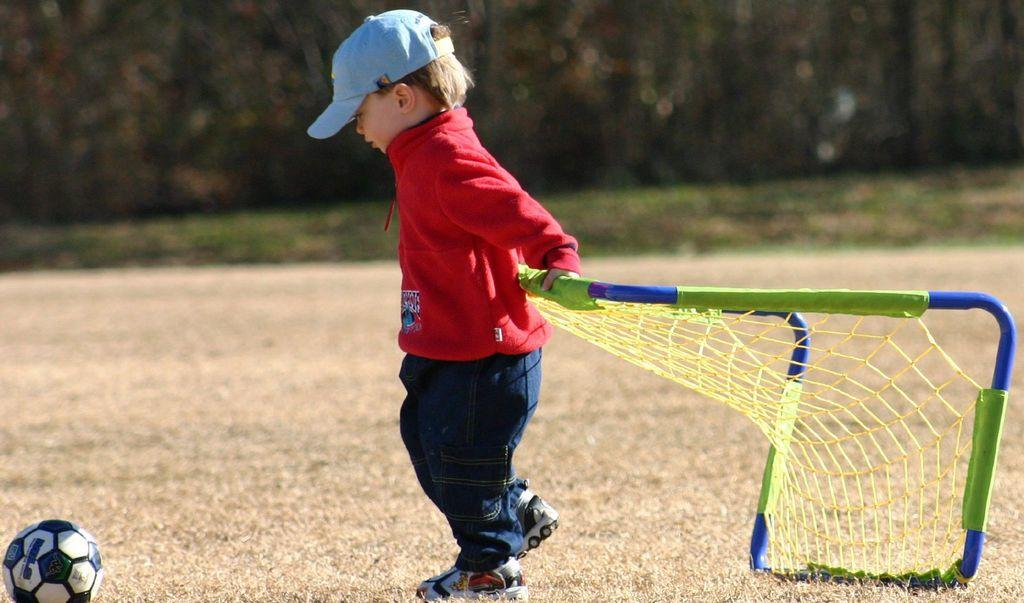Who is the main subject in the image? There is a boy in the image. What is the boy holding in the image? The boy is holding a net stand. Can you describe any other objects in the image? There is a ball in the bottom left corner of the image. How would you describe the background of the image? The background of the image is blurry. How many cats are playing with the ball in the image? There are no cats present in the image, and therefore no such activity can be observed. What is the boy trying to smash with the net stand in the image? There is no indication in the image that the boy is trying to smash anything with the net stand. 